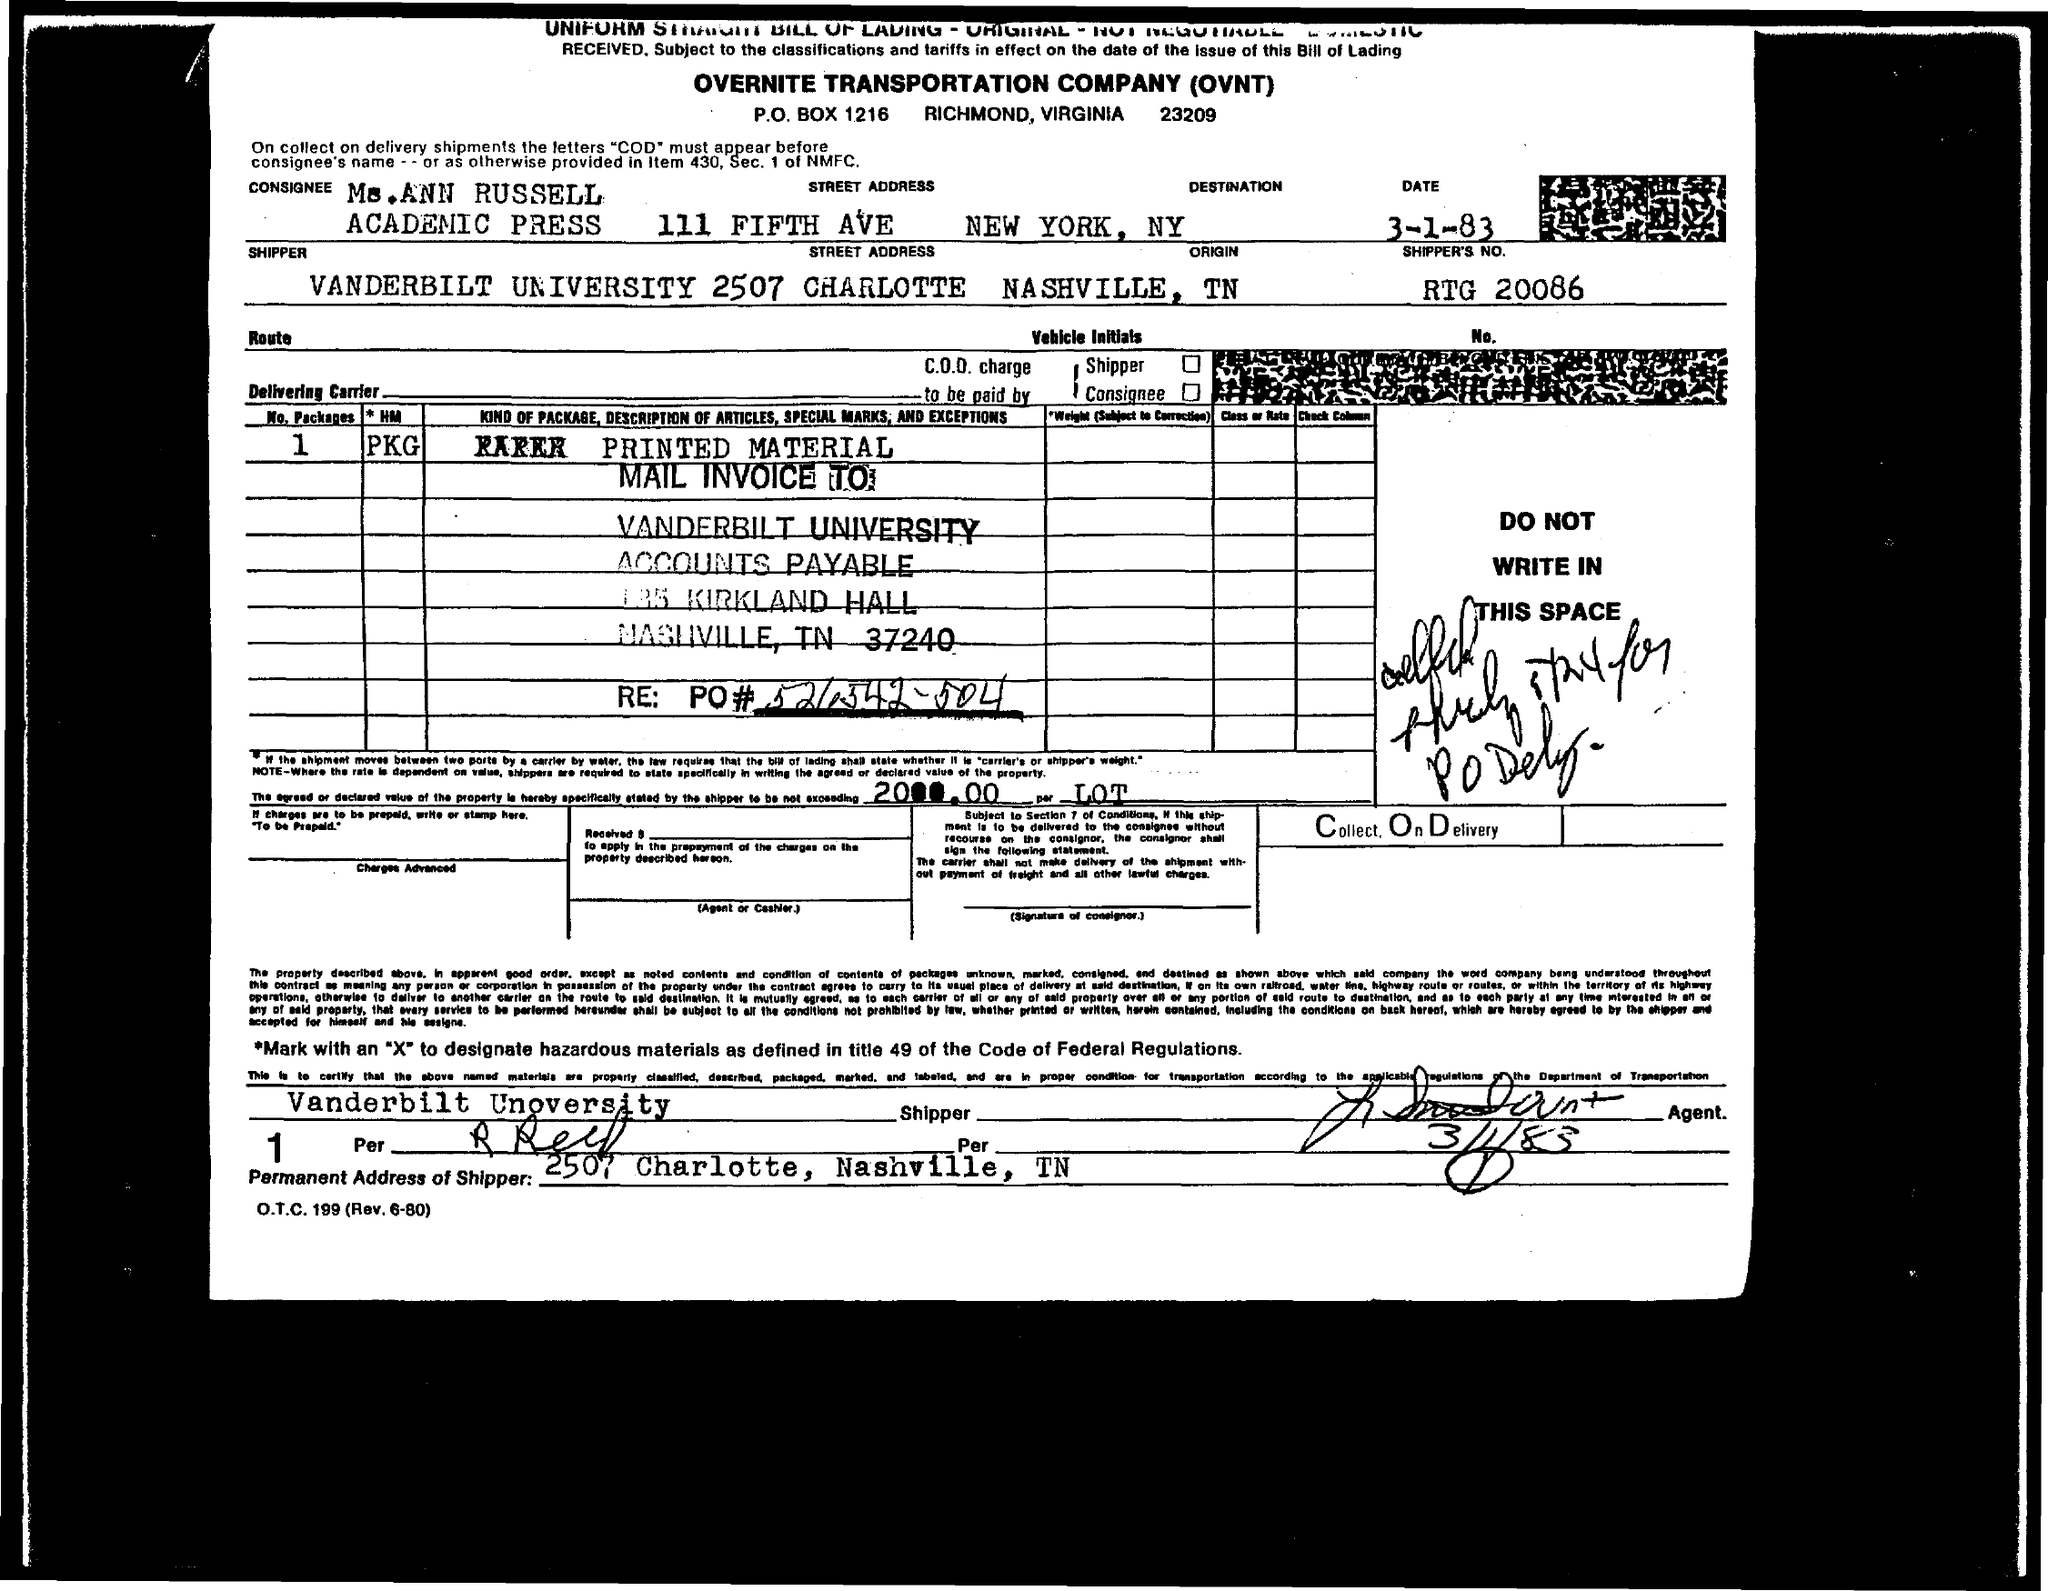What is the fullform of OVNT?
Your response must be concise. OVERNITE TRANSPORTATION COMPANY. What is the consignee name mentioned in the form?
Make the answer very short. Ms.ANN RUSELL. What is the shipper's no mentioned in the form?
Give a very brief answer. RTG 20086. What is the destination for the consignment?
Your answer should be compact. NEW YORK, NY. Who is the shipper for the consignment?
Make the answer very short. Vanderbilt University. What is the permanent address of the shipper?
Your answer should be very brief. 2507 Charlotte, Nashville, tn. 